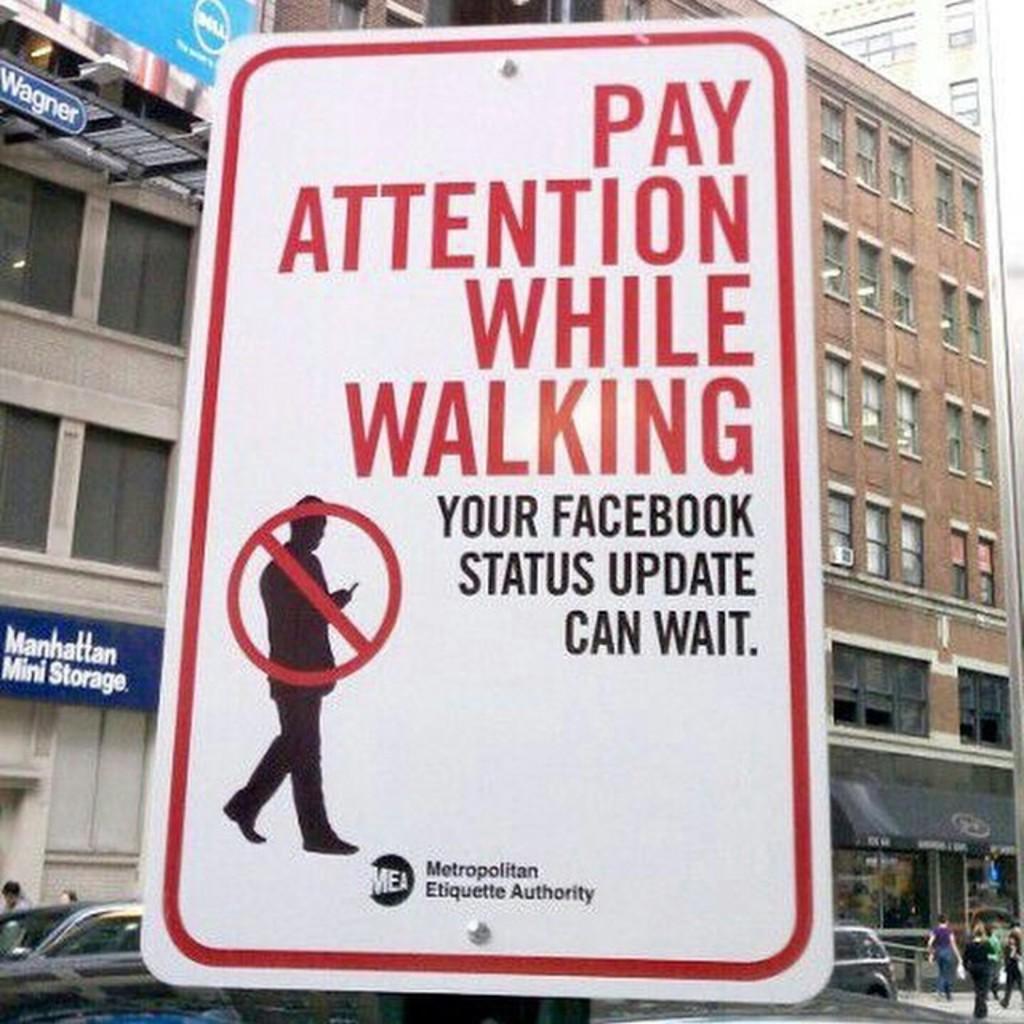What should you do while walking?
Ensure brevity in your answer.  Pay attention. What can wait?
Provide a short and direct response. Facebook status update. 